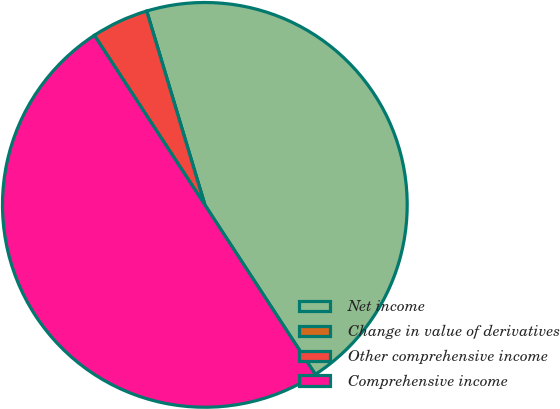Convert chart to OTSL. <chart><loc_0><loc_0><loc_500><loc_500><pie_chart><fcel>Net income<fcel>Change in value of derivatives<fcel>Other comprehensive income<fcel>Comprehensive income<nl><fcel>45.45%<fcel>0.0%<fcel>4.55%<fcel>50.0%<nl></chart> 